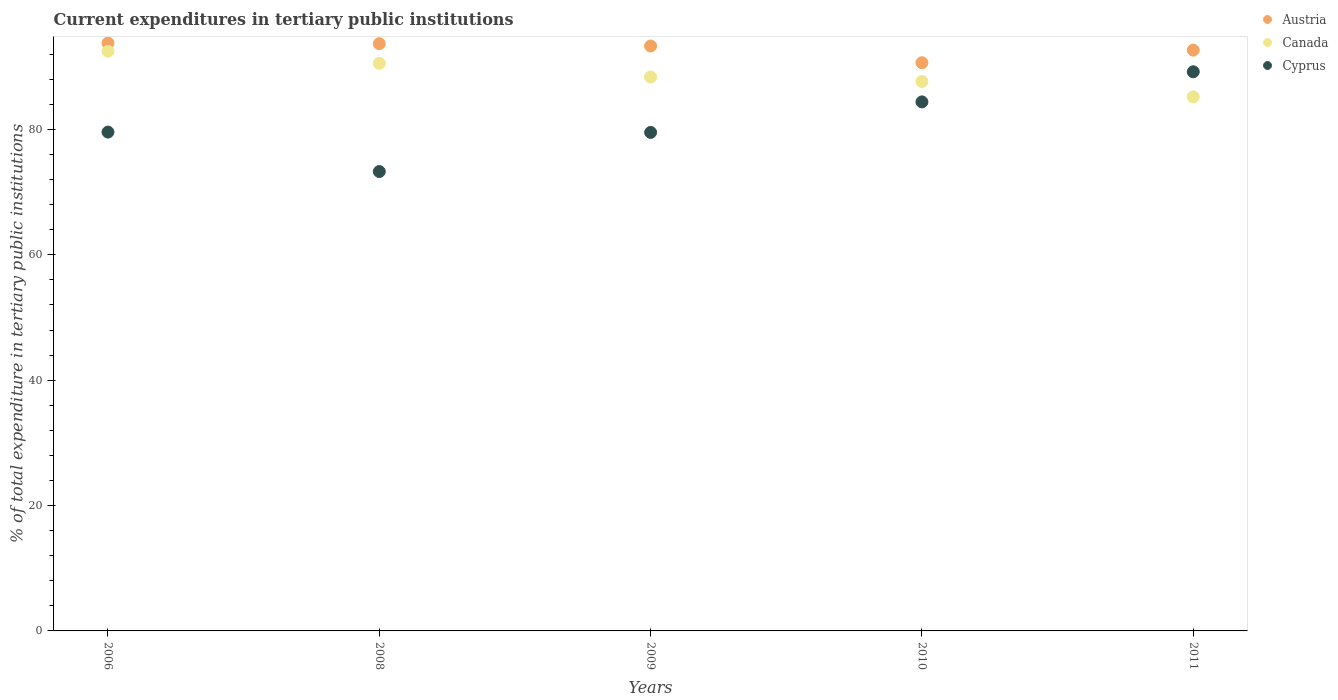How many different coloured dotlines are there?
Your response must be concise. 3. Is the number of dotlines equal to the number of legend labels?
Your answer should be compact. Yes. What is the current expenditures in tertiary public institutions in Canada in 2011?
Offer a terse response. 85.2. Across all years, what is the maximum current expenditures in tertiary public institutions in Cyprus?
Offer a terse response. 89.19. Across all years, what is the minimum current expenditures in tertiary public institutions in Austria?
Provide a succinct answer. 90.64. In which year was the current expenditures in tertiary public institutions in Canada minimum?
Keep it short and to the point. 2011. What is the total current expenditures in tertiary public institutions in Canada in the graph?
Offer a terse response. 444.22. What is the difference between the current expenditures in tertiary public institutions in Canada in 2006 and that in 2009?
Your answer should be very brief. 4.1. What is the difference between the current expenditures in tertiary public institutions in Austria in 2006 and the current expenditures in tertiary public institutions in Canada in 2008?
Provide a succinct answer. 3.25. What is the average current expenditures in tertiary public institutions in Cyprus per year?
Offer a very short reply. 81.19. In the year 2009, what is the difference between the current expenditures in tertiary public institutions in Canada and current expenditures in tertiary public institutions in Cyprus?
Keep it short and to the point. 8.84. What is the ratio of the current expenditures in tertiary public institutions in Austria in 2009 to that in 2011?
Your response must be concise. 1.01. Is the difference between the current expenditures in tertiary public institutions in Canada in 2009 and 2010 greater than the difference between the current expenditures in tertiary public institutions in Cyprus in 2009 and 2010?
Your answer should be compact. Yes. What is the difference between the highest and the second highest current expenditures in tertiary public institutions in Austria?
Make the answer very short. 0.11. What is the difference between the highest and the lowest current expenditures in tertiary public institutions in Canada?
Ensure brevity in your answer.  7.27. Is the sum of the current expenditures in tertiary public institutions in Austria in 2009 and 2011 greater than the maximum current expenditures in tertiary public institutions in Cyprus across all years?
Make the answer very short. Yes. Does the current expenditures in tertiary public institutions in Austria monotonically increase over the years?
Make the answer very short. No. Is the current expenditures in tertiary public institutions in Canada strictly greater than the current expenditures in tertiary public institutions in Austria over the years?
Your answer should be very brief. No. Is the current expenditures in tertiary public institutions in Cyprus strictly less than the current expenditures in tertiary public institutions in Austria over the years?
Offer a very short reply. Yes. How many dotlines are there?
Give a very brief answer. 3. Are the values on the major ticks of Y-axis written in scientific E-notation?
Ensure brevity in your answer.  No. Does the graph contain any zero values?
Provide a succinct answer. No. Where does the legend appear in the graph?
Your answer should be very brief. Top right. How many legend labels are there?
Provide a succinct answer. 3. What is the title of the graph?
Your answer should be compact. Current expenditures in tertiary public institutions. What is the label or title of the Y-axis?
Your response must be concise. % of total expenditure in tertiary public institutions. What is the % of total expenditure in tertiary public institutions in Austria in 2006?
Give a very brief answer. 93.78. What is the % of total expenditure in tertiary public institutions in Canada in 2006?
Your answer should be compact. 92.47. What is the % of total expenditure in tertiary public institutions of Cyprus in 2006?
Give a very brief answer. 79.57. What is the % of total expenditure in tertiary public institutions in Austria in 2008?
Ensure brevity in your answer.  93.68. What is the % of total expenditure in tertiary public institutions of Canada in 2008?
Make the answer very short. 90.54. What is the % of total expenditure in tertiary public institutions in Cyprus in 2008?
Ensure brevity in your answer.  73.28. What is the % of total expenditure in tertiary public institutions in Austria in 2009?
Give a very brief answer. 93.3. What is the % of total expenditure in tertiary public institutions of Canada in 2009?
Your answer should be very brief. 88.37. What is the % of total expenditure in tertiary public institutions of Cyprus in 2009?
Your answer should be compact. 79.52. What is the % of total expenditure in tertiary public institutions in Austria in 2010?
Your response must be concise. 90.64. What is the % of total expenditure in tertiary public institutions in Canada in 2010?
Offer a terse response. 87.65. What is the % of total expenditure in tertiary public institutions in Cyprus in 2010?
Give a very brief answer. 84.39. What is the % of total expenditure in tertiary public institutions of Austria in 2011?
Ensure brevity in your answer.  92.65. What is the % of total expenditure in tertiary public institutions of Canada in 2011?
Offer a terse response. 85.2. What is the % of total expenditure in tertiary public institutions in Cyprus in 2011?
Your answer should be compact. 89.19. Across all years, what is the maximum % of total expenditure in tertiary public institutions of Austria?
Keep it short and to the point. 93.78. Across all years, what is the maximum % of total expenditure in tertiary public institutions of Canada?
Give a very brief answer. 92.47. Across all years, what is the maximum % of total expenditure in tertiary public institutions in Cyprus?
Ensure brevity in your answer.  89.19. Across all years, what is the minimum % of total expenditure in tertiary public institutions of Austria?
Offer a terse response. 90.64. Across all years, what is the minimum % of total expenditure in tertiary public institutions in Canada?
Your answer should be compact. 85.2. Across all years, what is the minimum % of total expenditure in tertiary public institutions in Cyprus?
Your response must be concise. 73.28. What is the total % of total expenditure in tertiary public institutions in Austria in the graph?
Keep it short and to the point. 464.05. What is the total % of total expenditure in tertiary public institutions in Canada in the graph?
Your answer should be compact. 444.22. What is the total % of total expenditure in tertiary public institutions of Cyprus in the graph?
Give a very brief answer. 405.96. What is the difference between the % of total expenditure in tertiary public institutions in Austria in 2006 and that in 2008?
Offer a terse response. 0.11. What is the difference between the % of total expenditure in tertiary public institutions in Canada in 2006 and that in 2008?
Offer a very short reply. 1.93. What is the difference between the % of total expenditure in tertiary public institutions in Cyprus in 2006 and that in 2008?
Provide a short and direct response. 6.29. What is the difference between the % of total expenditure in tertiary public institutions in Austria in 2006 and that in 2009?
Your answer should be compact. 0.48. What is the difference between the % of total expenditure in tertiary public institutions of Canada in 2006 and that in 2009?
Your answer should be very brief. 4.1. What is the difference between the % of total expenditure in tertiary public institutions in Cyprus in 2006 and that in 2009?
Offer a terse response. 0.05. What is the difference between the % of total expenditure in tertiary public institutions of Austria in 2006 and that in 2010?
Offer a very short reply. 3.15. What is the difference between the % of total expenditure in tertiary public institutions of Canada in 2006 and that in 2010?
Ensure brevity in your answer.  4.82. What is the difference between the % of total expenditure in tertiary public institutions in Cyprus in 2006 and that in 2010?
Keep it short and to the point. -4.82. What is the difference between the % of total expenditure in tertiary public institutions in Austria in 2006 and that in 2011?
Your response must be concise. 1.14. What is the difference between the % of total expenditure in tertiary public institutions of Canada in 2006 and that in 2011?
Offer a very short reply. 7.27. What is the difference between the % of total expenditure in tertiary public institutions in Cyprus in 2006 and that in 2011?
Make the answer very short. -9.62. What is the difference between the % of total expenditure in tertiary public institutions in Austria in 2008 and that in 2009?
Ensure brevity in your answer.  0.37. What is the difference between the % of total expenditure in tertiary public institutions in Canada in 2008 and that in 2009?
Offer a terse response. 2.17. What is the difference between the % of total expenditure in tertiary public institutions in Cyprus in 2008 and that in 2009?
Provide a succinct answer. -6.24. What is the difference between the % of total expenditure in tertiary public institutions in Austria in 2008 and that in 2010?
Give a very brief answer. 3.04. What is the difference between the % of total expenditure in tertiary public institutions of Canada in 2008 and that in 2010?
Offer a terse response. 2.89. What is the difference between the % of total expenditure in tertiary public institutions in Cyprus in 2008 and that in 2010?
Ensure brevity in your answer.  -11.11. What is the difference between the % of total expenditure in tertiary public institutions of Austria in 2008 and that in 2011?
Provide a succinct answer. 1.03. What is the difference between the % of total expenditure in tertiary public institutions in Canada in 2008 and that in 2011?
Keep it short and to the point. 5.34. What is the difference between the % of total expenditure in tertiary public institutions in Cyprus in 2008 and that in 2011?
Give a very brief answer. -15.91. What is the difference between the % of total expenditure in tertiary public institutions of Austria in 2009 and that in 2010?
Give a very brief answer. 2.66. What is the difference between the % of total expenditure in tertiary public institutions of Canada in 2009 and that in 2010?
Provide a short and direct response. 0.71. What is the difference between the % of total expenditure in tertiary public institutions of Cyprus in 2009 and that in 2010?
Make the answer very short. -4.87. What is the difference between the % of total expenditure in tertiary public institutions in Austria in 2009 and that in 2011?
Your response must be concise. 0.66. What is the difference between the % of total expenditure in tertiary public institutions in Canada in 2009 and that in 2011?
Provide a short and direct response. 3.17. What is the difference between the % of total expenditure in tertiary public institutions of Cyprus in 2009 and that in 2011?
Provide a short and direct response. -9.67. What is the difference between the % of total expenditure in tertiary public institutions in Austria in 2010 and that in 2011?
Keep it short and to the point. -2.01. What is the difference between the % of total expenditure in tertiary public institutions of Canada in 2010 and that in 2011?
Keep it short and to the point. 2.45. What is the difference between the % of total expenditure in tertiary public institutions of Cyprus in 2010 and that in 2011?
Ensure brevity in your answer.  -4.8. What is the difference between the % of total expenditure in tertiary public institutions of Austria in 2006 and the % of total expenditure in tertiary public institutions of Canada in 2008?
Provide a succinct answer. 3.25. What is the difference between the % of total expenditure in tertiary public institutions in Austria in 2006 and the % of total expenditure in tertiary public institutions in Cyprus in 2008?
Your answer should be compact. 20.5. What is the difference between the % of total expenditure in tertiary public institutions in Canada in 2006 and the % of total expenditure in tertiary public institutions in Cyprus in 2008?
Provide a short and direct response. 19.19. What is the difference between the % of total expenditure in tertiary public institutions in Austria in 2006 and the % of total expenditure in tertiary public institutions in Canada in 2009?
Offer a very short reply. 5.42. What is the difference between the % of total expenditure in tertiary public institutions in Austria in 2006 and the % of total expenditure in tertiary public institutions in Cyprus in 2009?
Offer a very short reply. 14.26. What is the difference between the % of total expenditure in tertiary public institutions in Canada in 2006 and the % of total expenditure in tertiary public institutions in Cyprus in 2009?
Your answer should be very brief. 12.95. What is the difference between the % of total expenditure in tertiary public institutions in Austria in 2006 and the % of total expenditure in tertiary public institutions in Canada in 2010?
Your answer should be compact. 6.13. What is the difference between the % of total expenditure in tertiary public institutions of Austria in 2006 and the % of total expenditure in tertiary public institutions of Cyprus in 2010?
Offer a very short reply. 9.39. What is the difference between the % of total expenditure in tertiary public institutions of Canada in 2006 and the % of total expenditure in tertiary public institutions of Cyprus in 2010?
Your answer should be compact. 8.08. What is the difference between the % of total expenditure in tertiary public institutions in Austria in 2006 and the % of total expenditure in tertiary public institutions in Canada in 2011?
Keep it short and to the point. 8.59. What is the difference between the % of total expenditure in tertiary public institutions of Austria in 2006 and the % of total expenditure in tertiary public institutions of Cyprus in 2011?
Provide a succinct answer. 4.59. What is the difference between the % of total expenditure in tertiary public institutions of Canada in 2006 and the % of total expenditure in tertiary public institutions of Cyprus in 2011?
Provide a short and direct response. 3.28. What is the difference between the % of total expenditure in tertiary public institutions in Austria in 2008 and the % of total expenditure in tertiary public institutions in Canada in 2009?
Offer a very short reply. 5.31. What is the difference between the % of total expenditure in tertiary public institutions in Austria in 2008 and the % of total expenditure in tertiary public institutions in Cyprus in 2009?
Your answer should be very brief. 14.15. What is the difference between the % of total expenditure in tertiary public institutions of Canada in 2008 and the % of total expenditure in tertiary public institutions of Cyprus in 2009?
Your answer should be compact. 11.02. What is the difference between the % of total expenditure in tertiary public institutions of Austria in 2008 and the % of total expenditure in tertiary public institutions of Canada in 2010?
Provide a short and direct response. 6.03. What is the difference between the % of total expenditure in tertiary public institutions of Austria in 2008 and the % of total expenditure in tertiary public institutions of Cyprus in 2010?
Make the answer very short. 9.29. What is the difference between the % of total expenditure in tertiary public institutions of Canada in 2008 and the % of total expenditure in tertiary public institutions of Cyprus in 2010?
Provide a short and direct response. 6.15. What is the difference between the % of total expenditure in tertiary public institutions in Austria in 2008 and the % of total expenditure in tertiary public institutions in Canada in 2011?
Your answer should be compact. 8.48. What is the difference between the % of total expenditure in tertiary public institutions in Austria in 2008 and the % of total expenditure in tertiary public institutions in Cyprus in 2011?
Make the answer very short. 4.48. What is the difference between the % of total expenditure in tertiary public institutions of Canada in 2008 and the % of total expenditure in tertiary public institutions of Cyprus in 2011?
Your response must be concise. 1.35. What is the difference between the % of total expenditure in tertiary public institutions in Austria in 2009 and the % of total expenditure in tertiary public institutions in Canada in 2010?
Your answer should be compact. 5.65. What is the difference between the % of total expenditure in tertiary public institutions of Austria in 2009 and the % of total expenditure in tertiary public institutions of Cyprus in 2010?
Provide a short and direct response. 8.91. What is the difference between the % of total expenditure in tertiary public institutions in Canada in 2009 and the % of total expenditure in tertiary public institutions in Cyprus in 2010?
Your answer should be compact. 3.97. What is the difference between the % of total expenditure in tertiary public institutions in Austria in 2009 and the % of total expenditure in tertiary public institutions in Canada in 2011?
Give a very brief answer. 8.11. What is the difference between the % of total expenditure in tertiary public institutions in Austria in 2009 and the % of total expenditure in tertiary public institutions in Cyprus in 2011?
Your answer should be very brief. 4.11. What is the difference between the % of total expenditure in tertiary public institutions in Canada in 2009 and the % of total expenditure in tertiary public institutions in Cyprus in 2011?
Give a very brief answer. -0.83. What is the difference between the % of total expenditure in tertiary public institutions in Austria in 2010 and the % of total expenditure in tertiary public institutions in Canada in 2011?
Your answer should be very brief. 5.44. What is the difference between the % of total expenditure in tertiary public institutions of Austria in 2010 and the % of total expenditure in tertiary public institutions of Cyprus in 2011?
Offer a very short reply. 1.45. What is the difference between the % of total expenditure in tertiary public institutions of Canada in 2010 and the % of total expenditure in tertiary public institutions of Cyprus in 2011?
Your response must be concise. -1.54. What is the average % of total expenditure in tertiary public institutions of Austria per year?
Your answer should be compact. 92.81. What is the average % of total expenditure in tertiary public institutions in Canada per year?
Keep it short and to the point. 88.84. What is the average % of total expenditure in tertiary public institutions of Cyprus per year?
Provide a succinct answer. 81.19. In the year 2006, what is the difference between the % of total expenditure in tertiary public institutions of Austria and % of total expenditure in tertiary public institutions of Canada?
Your answer should be compact. 1.32. In the year 2006, what is the difference between the % of total expenditure in tertiary public institutions of Austria and % of total expenditure in tertiary public institutions of Cyprus?
Provide a short and direct response. 14.21. In the year 2006, what is the difference between the % of total expenditure in tertiary public institutions of Canada and % of total expenditure in tertiary public institutions of Cyprus?
Make the answer very short. 12.9. In the year 2008, what is the difference between the % of total expenditure in tertiary public institutions of Austria and % of total expenditure in tertiary public institutions of Canada?
Provide a short and direct response. 3.14. In the year 2008, what is the difference between the % of total expenditure in tertiary public institutions in Austria and % of total expenditure in tertiary public institutions in Cyprus?
Make the answer very short. 20.4. In the year 2008, what is the difference between the % of total expenditure in tertiary public institutions of Canada and % of total expenditure in tertiary public institutions of Cyprus?
Keep it short and to the point. 17.26. In the year 2009, what is the difference between the % of total expenditure in tertiary public institutions of Austria and % of total expenditure in tertiary public institutions of Canada?
Keep it short and to the point. 4.94. In the year 2009, what is the difference between the % of total expenditure in tertiary public institutions in Austria and % of total expenditure in tertiary public institutions in Cyprus?
Offer a terse response. 13.78. In the year 2009, what is the difference between the % of total expenditure in tertiary public institutions of Canada and % of total expenditure in tertiary public institutions of Cyprus?
Offer a terse response. 8.84. In the year 2010, what is the difference between the % of total expenditure in tertiary public institutions in Austria and % of total expenditure in tertiary public institutions in Canada?
Give a very brief answer. 2.99. In the year 2010, what is the difference between the % of total expenditure in tertiary public institutions in Austria and % of total expenditure in tertiary public institutions in Cyprus?
Provide a short and direct response. 6.25. In the year 2010, what is the difference between the % of total expenditure in tertiary public institutions in Canada and % of total expenditure in tertiary public institutions in Cyprus?
Ensure brevity in your answer.  3.26. In the year 2011, what is the difference between the % of total expenditure in tertiary public institutions of Austria and % of total expenditure in tertiary public institutions of Canada?
Ensure brevity in your answer.  7.45. In the year 2011, what is the difference between the % of total expenditure in tertiary public institutions in Austria and % of total expenditure in tertiary public institutions in Cyprus?
Offer a terse response. 3.45. In the year 2011, what is the difference between the % of total expenditure in tertiary public institutions of Canada and % of total expenditure in tertiary public institutions of Cyprus?
Keep it short and to the point. -4. What is the ratio of the % of total expenditure in tertiary public institutions in Canada in 2006 to that in 2008?
Keep it short and to the point. 1.02. What is the ratio of the % of total expenditure in tertiary public institutions of Cyprus in 2006 to that in 2008?
Give a very brief answer. 1.09. What is the ratio of the % of total expenditure in tertiary public institutions in Austria in 2006 to that in 2009?
Your answer should be very brief. 1.01. What is the ratio of the % of total expenditure in tertiary public institutions in Canada in 2006 to that in 2009?
Make the answer very short. 1.05. What is the ratio of the % of total expenditure in tertiary public institutions of Cyprus in 2006 to that in 2009?
Give a very brief answer. 1. What is the ratio of the % of total expenditure in tertiary public institutions of Austria in 2006 to that in 2010?
Provide a succinct answer. 1.03. What is the ratio of the % of total expenditure in tertiary public institutions of Canada in 2006 to that in 2010?
Ensure brevity in your answer.  1.05. What is the ratio of the % of total expenditure in tertiary public institutions of Cyprus in 2006 to that in 2010?
Ensure brevity in your answer.  0.94. What is the ratio of the % of total expenditure in tertiary public institutions in Austria in 2006 to that in 2011?
Your answer should be very brief. 1.01. What is the ratio of the % of total expenditure in tertiary public institutions in Canada in 2006 to that in 2011?
Make the answer very short. 1.09. What is the ratio of the % of total expenditure in tertiary public institutions in Cyprus in 2006 to that in 2011?
Offer a very short reply. 0.89. What is the ratio of the % of total expenditure in tertiary public institutions of Canada in 2008 to that in 2009?
Your answer should be very brief. 1.02. What is the ratio of the % of total expenditure in tertiary public institutions in Cyprus in 2008 to that in 2009?
Offer a very short reply. 0.92. What is the ratio of the % of total expenditure in tertiary public institutions of Austria in 2008 to that in 2010?
Provide a succinct answer. 1.03. What is the ratio of the % of total expenditure in tertiary public institutions of Canada in 2008 to that in 2010?
Keep it short and to the point. 1.03. What is the ratio of the % of total expenditure in tertiary public institutions in Cyprus in 2008 to that in 2010?
Your response must be concise. 0.87. What is the ratio of the % of total expenditure in tertiary public institutions of Austria in 2008 to that in 2011?
Give a very brief answer. 1.01. What is the ratio of the % of total expenditure in tertiary public institutions of Canada in 2008 to that in 2011?
Give a very brief answer. 1.06. What is the ratio of the % of total expenditure in tertiary public institutions in Cyprus in 2008 to that in 2011?
Your response must be concise. 0.82. What is the ratio of the % of total expenditure in tertiary public institutions of Austria in 2009 to that in 2010?
Your response must be concise. 1.03. What is the ratio of the % of total expenditure in tertiary public institutions of Canada in 2009 to that in 2010?
Make the answer very short. 1.01. What is the ratio of the % of total expenditure in tertiary public institutions in Cyprus in 2009 to that in 2010?
Your answer should be very brief. 0.94. What is the ratio of the % of total expenditure in tertiary public institutions of Austria in 2009 to that in 2011?
Keep it short and to the point. 1.01. What is the ratio of the % of total expenditure in tertiary public institutions in Canada in 2009 to that in 2011?
Provide a succinct answer. 1.04. What is the ratio of the % of total expenditure in tertiary public institutions of Cyprus in 2009 to that in 2011?
Give a very brief answer. 0.89. What is the ratio of the % of total expenditure in tertiary public institutions in Austria in 2010 to that in 2011?
Give a very brief answer. 0.98. What is the ratio of the % of total expenditure in tertiary public institutions of Canada in 2010 to that in 2011?
Your answer should be very brief. 1.03. What is the ratio of the % of total expenditure in tertiary public institutions of Cyprus in 2010 to that in 2011?
Your answer should be very brief. 0.95. What is the difference between the highest and the second highest % of total expenditure in tertiary public institutions of Austria?
Provide a succinct answer. 0.11. What is the difference between the highest and the second highest % of total expenditure in tertiary public institutions of Canada?
Your response must be concise. 1.93. What is the difference between the highest and the second highest % of total expenditure in tertiary public institutions of Cyprus?
Offer a very short reply. 4.8. What is the difference between the highest and the lowest % of total expenditure in tertiary public institutions of Austria?
Offer a terse response. 3.15. What is the difference between the highest and the lowest % of total expenditure in tertiary public institutions of Canada?
Ensure brevity in your answer.  7.27. What is the difference between the highest and the lowest % of total expenditure in tertiary public institutions in Cyprus?
Your answer should be very brief. 15.91. 